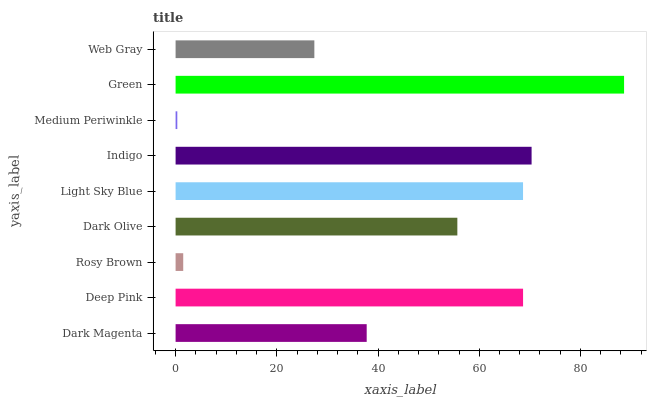Is Medium Periwinkle the minimum?
Answer yes or no. Yes. Is Green the maximum?
Answer yes or no. Yes. Is Deep Pink the minimum?
Answer yes or no. No. Is Deep Pink the maximum?
Answer yes or no. No. Is Deep Pink greater than Dark Magenta?
Answer yes or no. Yes. Is Dark Magenta less than Deep Pink?
Answer yes or no. Yes. Is Dark Magenta greater than Deep Pink?
Answer yes or no. No. Is Deep Pink less than Dark Magenta?
Answer yes or no. No. Is Dark Olive the high median?
Answer yes or no. Yes. Is Dark Olive the low median?
Answer yes or no. Yes. Is Rosy Brown the high median?
Answer yes or no. No. Is Light Sky Blue the low median?
Answer yes or no. No. 